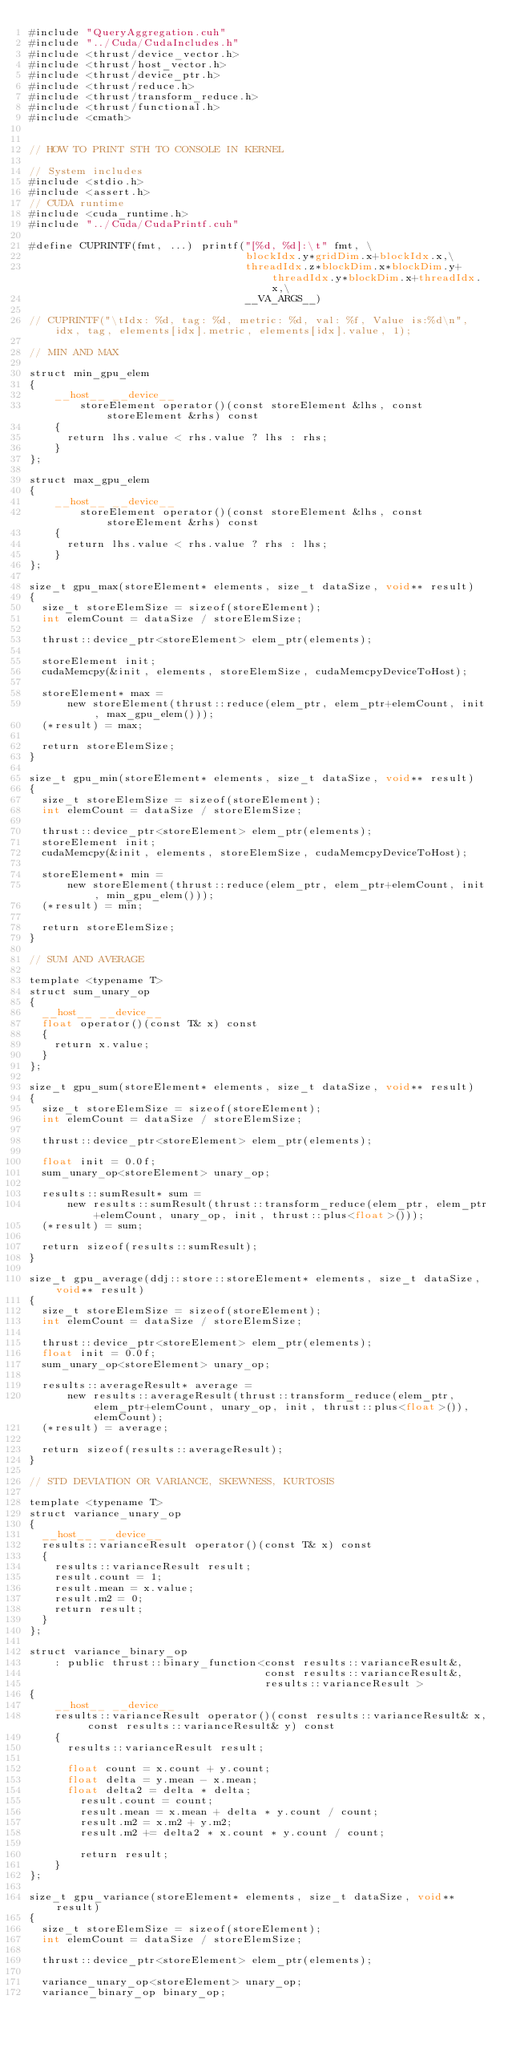<code> <loc_0><loc_0><loc_500><loc_500><_Cuda_>#include "QueryAggregation.cuh"
#include "../Cuda/CudaIncludes.h"
#include <thrust/device_vector.h>
#include <thrust/host_vector.h>
#include <thrust/device_ptr.h>
#include <thrust/reduce.h>
#include <thrust/transform_reduce.h>
#include <thrust/functional.h>
#include <cmath>


// HOW TO PRINT STH TO CONSOLE IN KERNEL

// System includes
#include <stdio.h>
#include <assert.h>
// CUDA runtime
#include <cuda_runtime.h>
#include "../Cuda/CudaPrintf.cuh"

#define CUPRINTF(fmt, ...) printf("[%d, %d]:\t" fmt, \
                                  blockIdx.y*gridDim.x+blockIdx.x,\
                                  threadIdx.z*blockDim.x*blockDim.y+threadIdx.y*blockDim.x+threadIdx.x,\
                                  __VA_ARGS__)

// CUPRINTF("\tIdx: %d, tag: %d, metric: %d, val: %f, Value is:%d\n", idx, tag, elements[idx].metric, elements[idx].value, 1);

// MIN AND MAX

struct min_gpu_elem
{
    __host__ __device__
        storeElement operator()(const storeElement &lhs, const storeElement &rhs) const
    {
    	return lhs.value < rhs.value ? lhs : rhs;
    }
};

struct max_gpu_elem
{
    __host__ __device__
        storeElement operator()(const storeElement &lhs, const storeElement &rhs) const
    {
    	return lhs.value < rhs.value ? rhs : lhs;
    }
};

size_t gpu_max(storeElement* elements, size_t dataSize, void** result)
{
	size_t storeElemSize = sizeof(storeElement);
	int elemCount = dataSize / storeElemSize;

	thrust::device_ptr<storeElement> elem_ptr(elements);

	storeElement init;
	cudaMemcpy(&init, elements, storeElemSize, cudaMemcpyDeviceToHost);

	storeElement* max =
			new storeElement(thrust::reduce(elem_ptr, elem_ptr+elemCount, init, max_gpu_elem()));
	(*result) = max;

	return storeElemSize;
}

size_t gpu_min(storeElement* elements, size_t dataSize, void** result)
{
	size_t storeElemSize = sizeof(storeElement);
	int elemCount = dataSize / storeElemSize;

	thrust::device_ptr<storeElement> elem_ptr(elements);
	storeElement init;
	cudaMemcpy(&init, elements, storeElemSize, cudaMemcpyDeviceToHost);

	storeElement* min =
			new storeElement(thrust::reduce(elem_ptr, elem_ptr+elemCount, init, min_gpu_elem()));
	(*result) = min;

	return storeElemSize;
}

// SUM AND AVERAGE

template <typename T>
struct sum_unary_op
{
	__host__ __device__
	float operator()(const T& x) const
	{
		return x.value;
	}
};

size_t gpu_sum(storeElement* elements, size_t dataSize, void** result)
{
	size_t storeElemSize = sizeof(storeElement);
	int elemCount = dataSize / storeElemSize;

	thrust::device_ptr<storeElement> elem_ptr(elements);

	float init = 0.0f;
	sum_unary_op<storeElement> unary_op;

	results::sumResult* sum =
			new results::sumResult(thrust::transform_reduce(elem_ptr, elem_ptr+elemCount, unary_op, init, thrust::plus<float>()));
	(*result) = sum;

	return sizeof(results::sumResult);
}

size_t gpu_average(ddj::store::storeElement* elements, size_t dataSize, void** result)
{
	size_t storeElemSize = sizeof(storeElement);
	int elemCount = dataSize / storeElemSize;

	thrust::device_ptr<storeElement> elem_ptr(elements);
	float init = 0.0f;
	sum_unary_op<storeElement> unary_op;

	results::averageResult* average =
			new results::averageResult(thrust::transform_reduce(elem_ptr, elem_ptr+elemCount, unary_op, init, thrust::plus<float>()), elemCount);
	(*result) = average;

	return sizeof(results::averageResult);
}

// STD DEVIATION OR VARIANCE, SKEWNESS, KURTOSIS

template <typename T>
struct variance_unary_op
{
	__host__ __device__
	results::varianceResult operator()(const T& x) const
	{
		results::varianceResult result;
		result.count = 1;
		result.mean = x.value;
		result.m2 = 0;
		return result;
	}
};

struct variance_binary_op
    : public thrust::binary_function<const results::varianceResult&,
                                     const results::varianceResult&,
                                     results::varianceResult >
{
    __host__ __device__
    results::varianceResult operator()(const results::varianceResult& x, const results::varianceResult& y) const
    {
    	results::varianceResult result;

    	float count = x.count + y.count;
    	float delta = y.mean - x.mean;
    	float delta2 = delta * delta;
        result.count = count;
        result.mean = x.mean + delta * y.count / count;
        result.m2 = x.m2 + y.m2;
        result.m2 += delta2 * x.count * y.count / count;

        return result;
    }
};

size_t gpu_variance(storeElement* elements, size_t dataSize, void** result)
{
	size_t storeElemSize = sizeof(storeElement);
	int elemCount = dataSize / storeElemSize;

	thrust::device_ptr<storeElement> elem_ptr(elements);

	variance_unary_op<storeElement> unary_op;
	variance_binary_op binary_op;</code> 